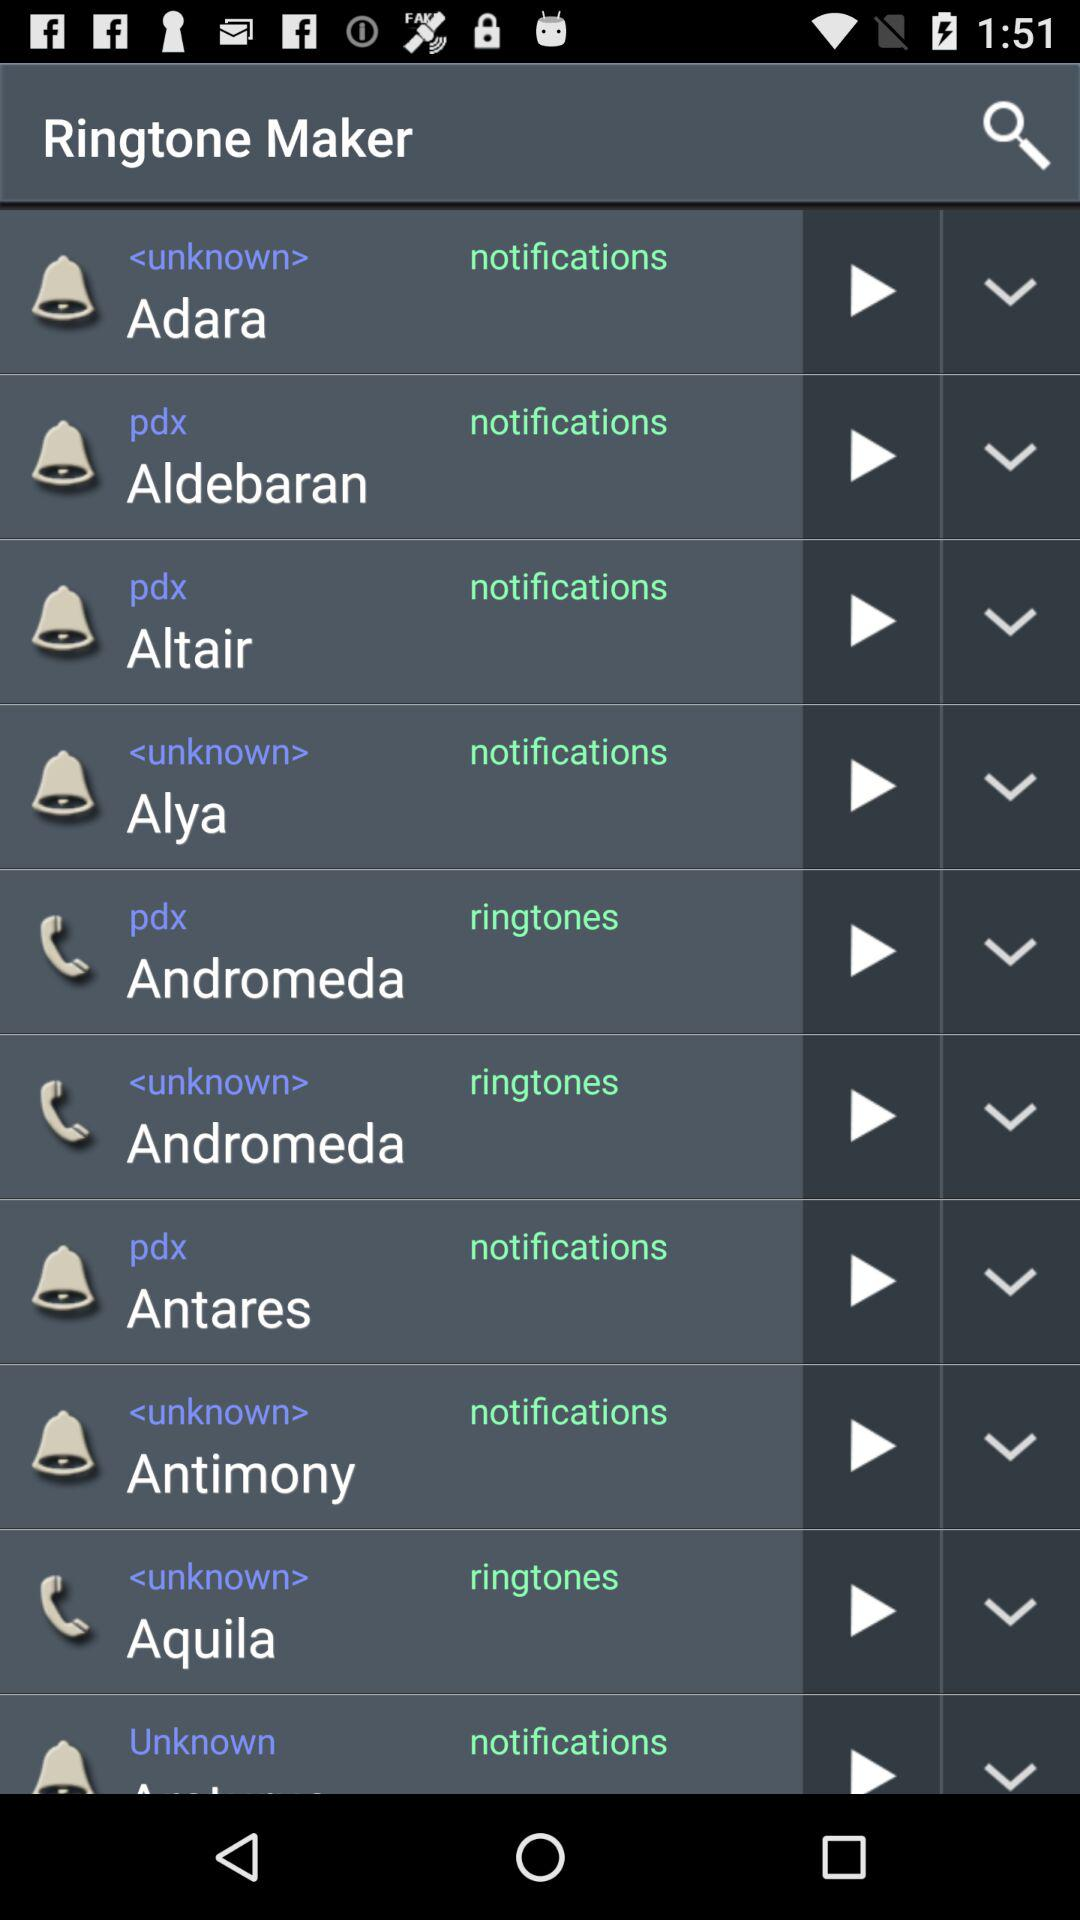What is the duration of the ringtone "Adara"?
When the provided information is insufficient, respond with <no answer>. <no answer> 